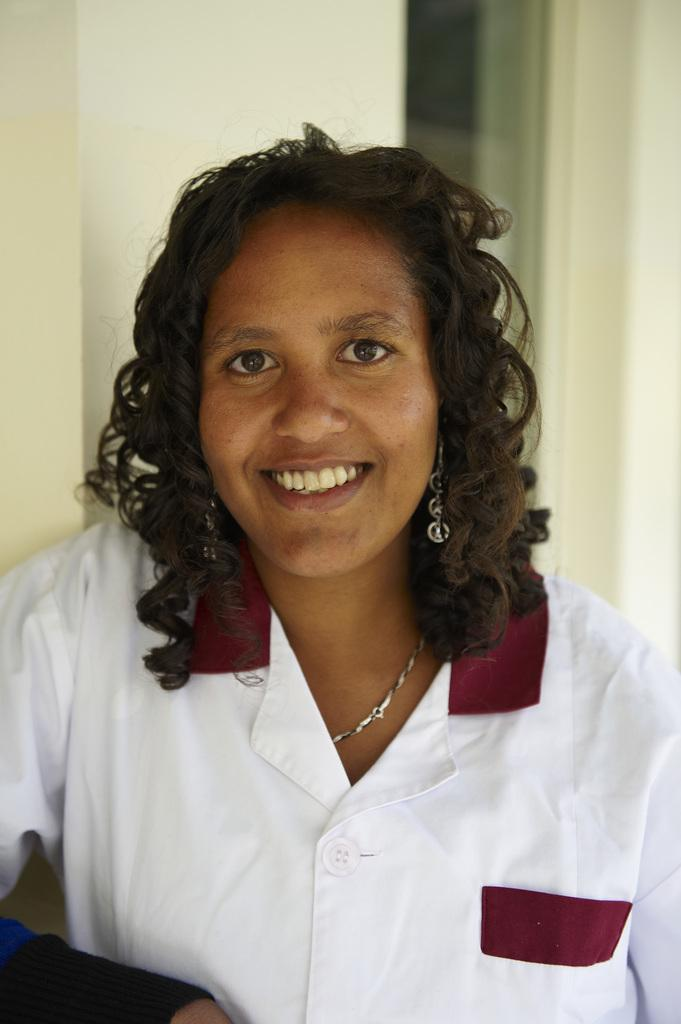Who is present in the image? There is a woman in the image. What is the woman wearing? The woman is wearing a white dress. What expression does the woman have? The woman is smiling. What can be seen in the background of the image? There is a window and a wall visible in the background of the image. What type of lamp is visible in the image? There is no lamp present in the image. Is there a truck visible in the image? No, there is no truck visible in the image. 